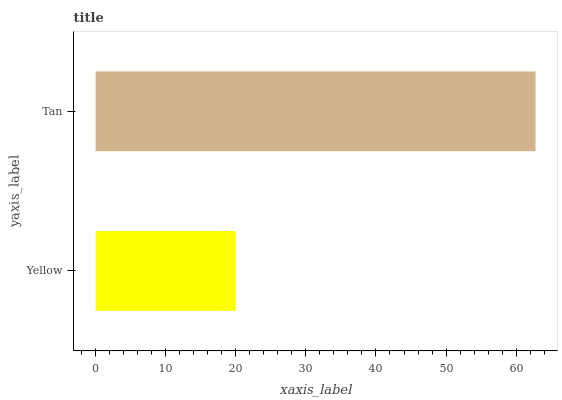Is Yellow the minimum?
Answer yes or no. Yes. Is Tan the maximum?
Answer yes or no. Yes. Is Tan the minimum?
Answer yes or no. No. Is Tan greater than Yellow?
Answer yes or no. Yes. Is Yellow less than Tan?
Answer yes or no. Yes. Is Yellow greater than Tan?
Answer yes or no. No. Is Tan less than Yellow?
Answer yes or no. No. Is Tan the high median?
Answer yes or no. Yes. Is Yellow the low median?
Answer yes or no. Yes. Is Yellow the high median?
Answer yes or no. No. Is Tan the low median?
Answer yes or no. No. 